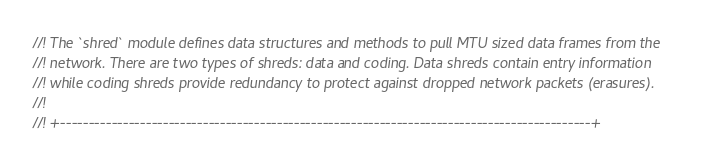Convert code to text. <code><loc_0><loc_0><loc_500><loc_500><_Rust_>//! The `shred` module defines data structures and methods to pull MTU sized data frames from the
//! network. There are two types of shreds: data and coding. Data shreds contain entry information
//! while coding shreds provide redundancy to protect against dropped network packets (erasures).
//!
//! +---------------------------------------------------------------------------------------------+</code> 